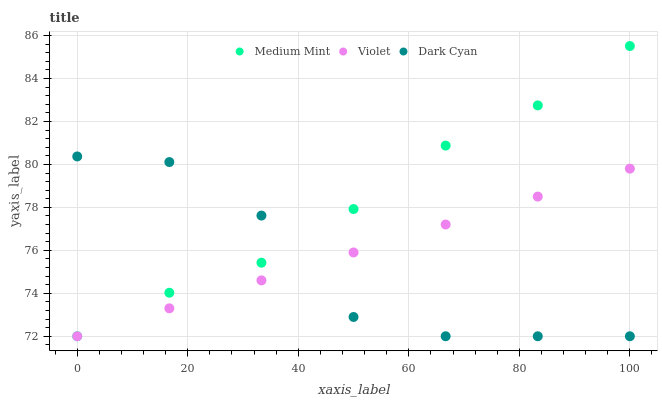Does Dark Cyan have the minimum area under the curve?
Answer yes or no. Yes. Does Medium Mint have the maximum area under the curve?
Answer yes or no. Yes. Does Violet have the minimum area under the curve?
Answer yes or no. No. Does Violet have the maximum area under the curve?
Answer yes or no. No. Is Violet the smoothest?
Answer yes or no. Yes. Is Dark Cyan the roughest?
Answer yes or no. Yes. Is Dark Cyan the smoothest?
Answer yes or no. No. Is Violet the roughest?
Answer yes or no. No. Does Medium Mint have the lowest value?
Answer yes or no. Yes. Does Medium Mint have the highest value?
Answer yes or no. Yes. Does Dark Cyan have the highest value?
Answer yes or no. No. Does Dark Cyan intersect Medium Mint?
Answer yes or no. Yes. Is Dark Cyan less than Medium Mint?
Answer yes or no. No. Is Dark Cyan greater than Medium Mint?
Answer yes or no. No. 